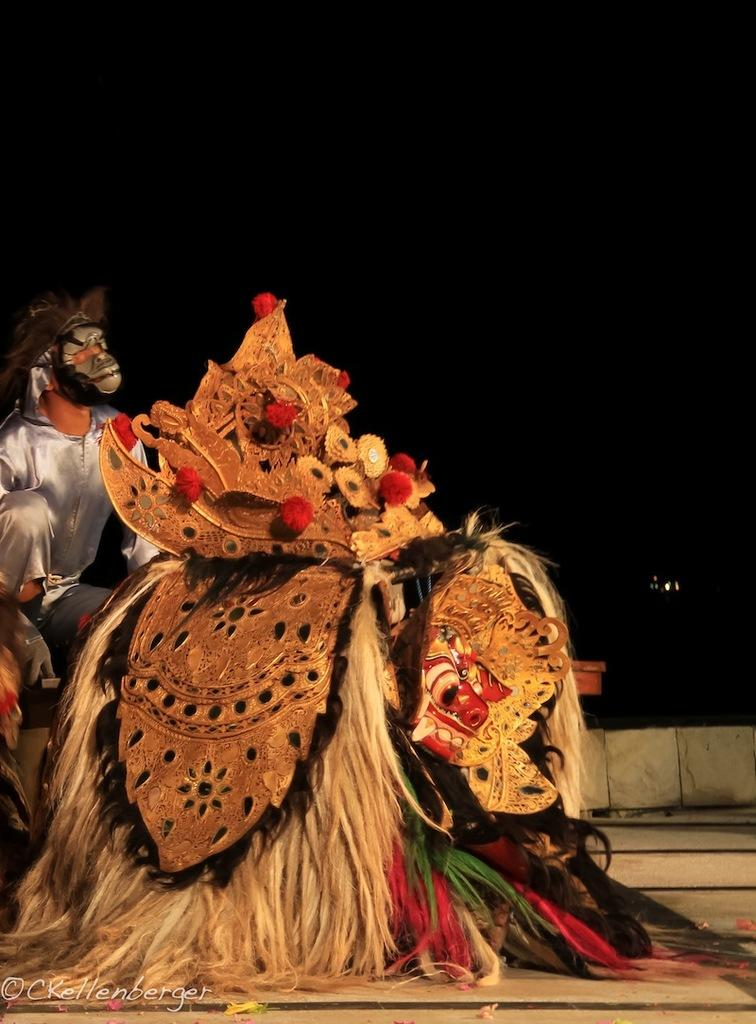What is the main subject of the picture? The main subject of the picture is a costume. Can you describe the person's attire in the image? The person is wearing a white, shining shirt. What is the color of the background in the image? The background of the image is dark. Can you tell me how many fights are happening in the background of the image? There is no fight present in the image; the background is dark. What type of ocean can be seen in the image? There is no ocean present in the image; it features a costume and a person wearing a white, shining shirt. 